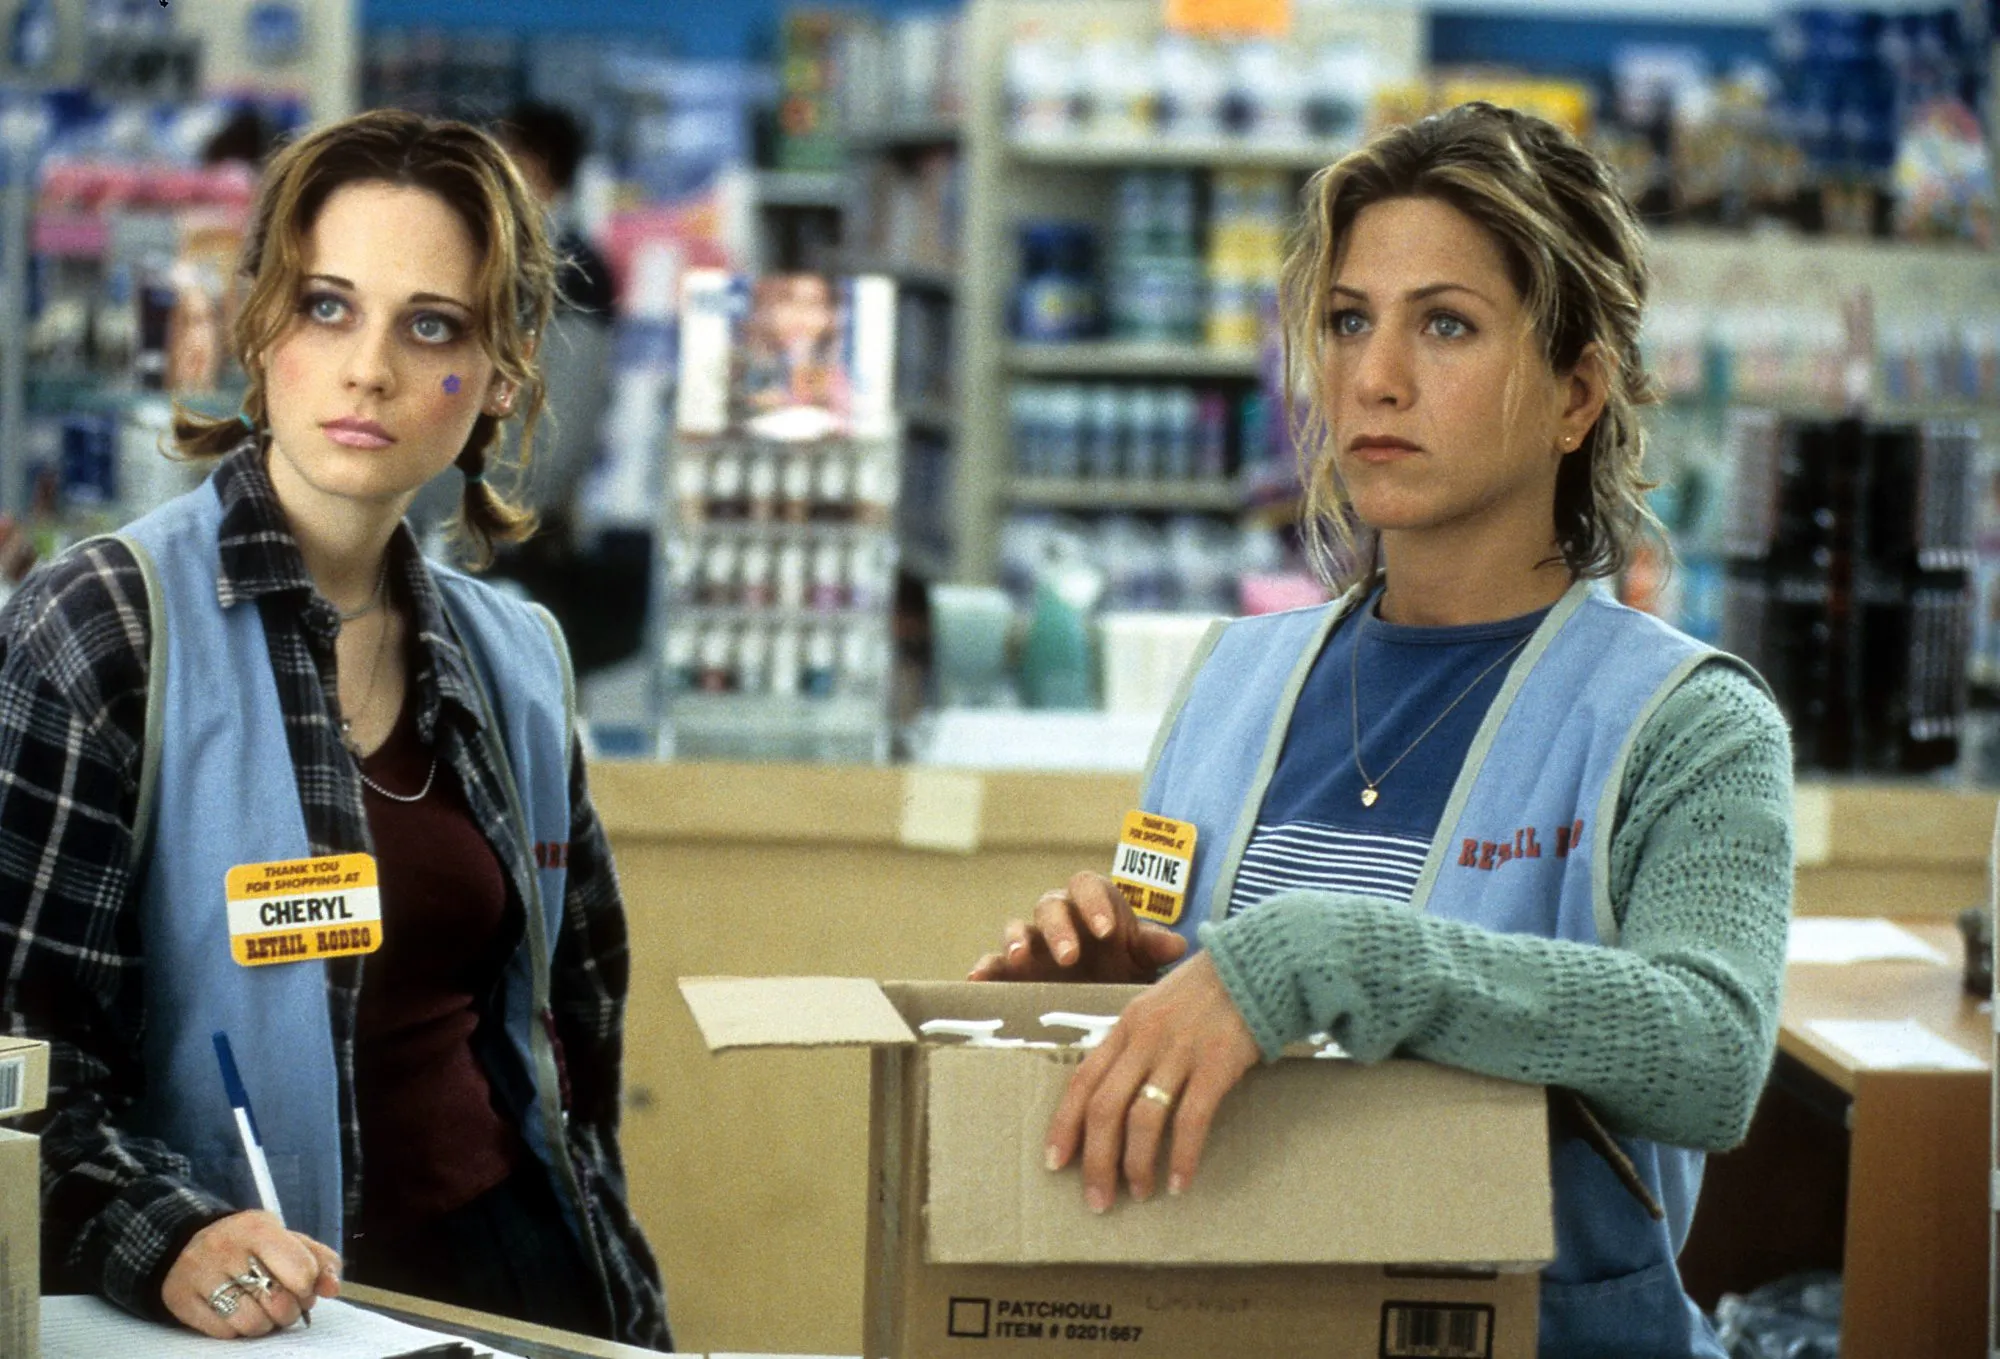What's happening in the scene? In this image from the movie 'The Good Girl', two characters portrayed by Zooey Deschanel and Jennifer Aniston are in a store environment. Zooey Deschanel, standing on the left, is dressed in a casual outfit with a red name tag reading 'Cheryl'. Jennifer Aniston, on the right, is wearing a light blue vest with a yellow name tag reading 'Justine' and is holding a cardboard box filled with products. Both women have serious, concerned expressions and are looking towards something off to their right, suggesting that they may be reacting to an unfolding situation. 